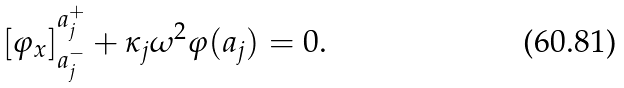Convert formula to latex. <formula><loc_0><loc_0><loc_500><loc_500>[ \varphi _ { x } ] _ { a _ { j } ^ { - } } ^ { a _ { j } ^ { + } } + \kappa _ { j } \omega ^ { 2 } \varphi ( a _ { j } ) = 0 .</formula> 